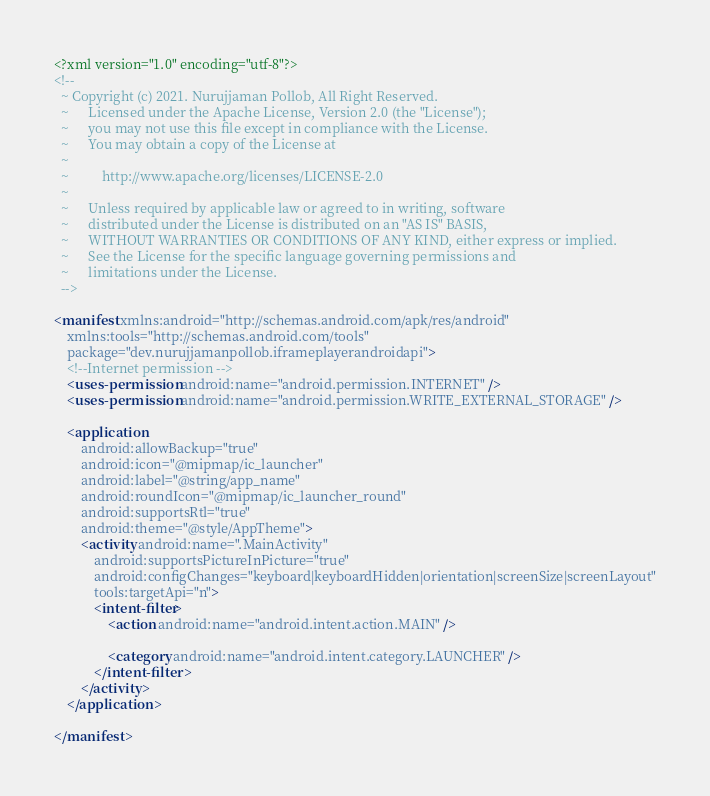<code> <loc_0><loc_0><loc_500><loc_500><_XML_><?xml version="1.0" encoding="utf-8"?>
<!--
  ~ Copyright (c) 2021. Nurujjaman Pollob, All Right Reserved.
  ~      Licensed under the Apache License, Version 2.0 (the "License");
  ~      you may not use this file except in compliance with the License.
  ~      You may obtain a copy of the License at
  ~
  ~          http://www.apache.org/licenses/LICENSE-2.0
  ~
  ~      Unless required by applicable law or agreed to in writing, software
  ~      distributed under the License is distributed on an "AS IS" BASIS,
  ~      WITHOUT WARRANTIES OR CONDITIONS OF ANY KIND, either express or implied.
  ~      See the License for the specific language governing permissions and
  ~      limitations under the License.
  -->

<manifest xmlns:android="http://schemas.android.com/apk/res/android"
    xmlns:tools="http://schemas.android.com/tools"
    package="dev.nurujjamanpollob.iframeplayerandroidapi">
    <!--Internet permission -->
    <uses-permission android:name="android.permission.INTERNET" />
    <uses-permission android:name="android.permission.WRITE_EXTERNAL_STORAGE" />

    <application
        android:allowBackup="true"
        android:icon="@mipmap/ic_launcher"
        android:label="@string/app_name"
        android:roundIcon="@mipmap/ic_launcher_round"
        android:supportsRtl="true"
        android:theme="@style/AppTheme">
        <activity android:name=".MainActivity"
            android:supportsPictureInPicture="true"
            android:configChanges="keyboard|keyboardHidden|orientation|screenSize|screenLayout"
            tools:targetApi="n">
            <intent-filter>
                <action android:name="android.intent.action.MAIN" />

                <category android:name="android.intent.category.LAUNCHER" />
            </intent-filter>
        </activity>
    </application>

</manifest></code> 